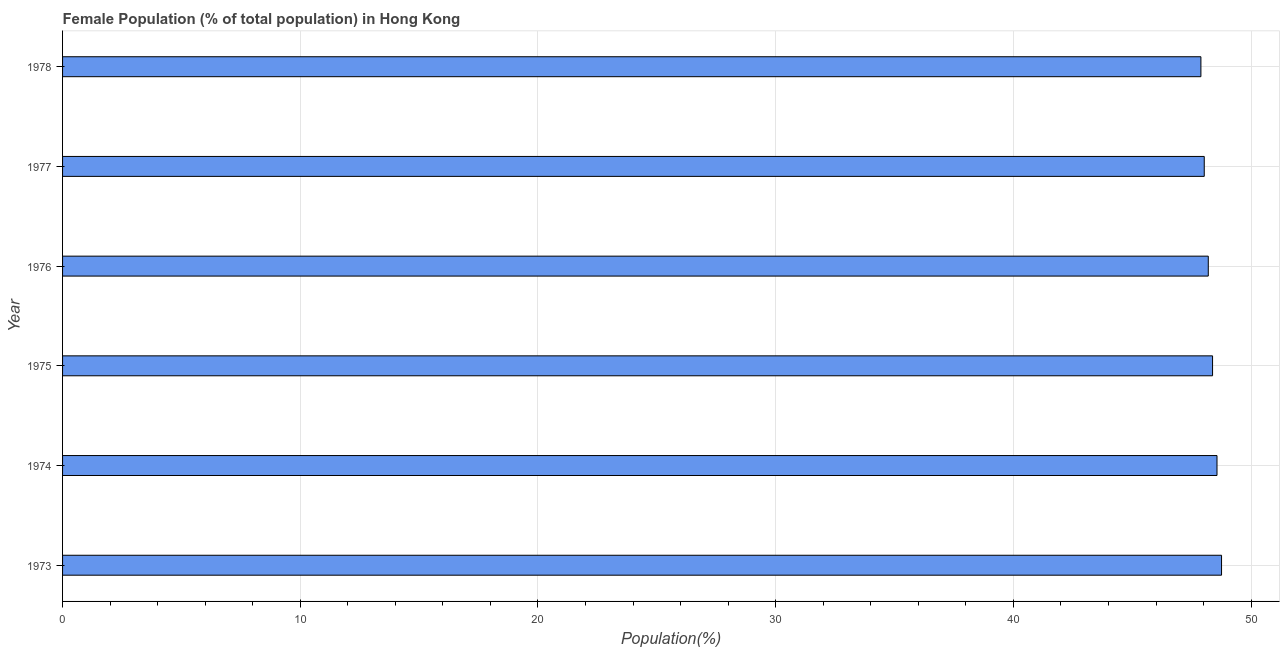What is the title of the graph?
Make the answer very short. Female Population (% of total population) in Hong Kong. What is the label or title of the X-axis?
Your response must be concise. Population(%). What is the female population in 1975?
Ensure brevity in your answer.  48.38. Across all years, what is the maximum female population?
Provide a succinct answer. 48.76. Across all years, what is the minimum female population?
Keep it short and to the point. 47.89. In which year was the female population maximum?
Your answer should be very brief. 1973. In which year was the female population minimum?
Ensure brevity in your answer.  1978. What is the sum of the female population?
Offer a terse response. 289.82. What is the difference between the female population in 1974 and 1977?
Ensure brevity in your answer.  0.54. What is the average female population per year?
Offer a very short reply. 48.3. What is the median female population?
Give a very brief answer. 48.29. In how many years, is the female population greater than 24 %?
Provide a short and direct response. 6. Do a majority of the years between 1977 and 1973 (inclusive) have female population greater than 10 %?
Give a very brief answer. Yes. Is the difference between the female population in 1973 and 1974 greater than the difference between any two years?
Your response must be concise. No. What is the difference between the highest and the second highest female population?
Provide a short and direct response. 0.19. Is the sum of the female population in 1975 and 1976 greater than the maximum female population across all years?
Offer a terse response. Yes. What is the difference between the highest and the lowest female population?
Keep it short and to the point. 0.87. In how many years, is the female population greater than the average female population taken over all years?
Provide a succinct answer. 3. How many years are there in the graph?
Your answer should be compact. 6. What is the difference between two consecutive major ticks on the X-axis?
Your answer should be very brief. 10. What is the Population(%) of 1973?
Your answer should be very brief. 48.76. What is the Population(%) in 1974?
Your response must be concise. 48.57. What is the Population(%) of 1975?
Keep it short and to the point. 48.38. What is the Population(%) in 1976?
Ensure brevity in your answer.  48.2. What is the Population(%) in 1977?
Provide a succinct answer. 48.03. What is the Population(%) in 1978?
Offer a terse response. 47.89. What is the difference between the Population(%) in 1973 and 1974?
Your response must be concise. 0.19. What is the difference between the Population(%) in 1973 and 1975?
Give a very brief answer. 0.38. What is the difference between the Population(%) in 1973 and 1976?
Provide a short and direct response. 0.56. What is the difference between the Population(%) in 1973 and 1977?
Offer a terse response. 0.73. What is the difference between the Population(%) in 1973 and 1978?
Provide a short and direct response. 0.87. What is the difference between the Population(%) in 1974 and 1975?
Keep it short and to the point. 0.19. What is the difference between the Population(%) in 1974 and 1976?
Provide a short and direct response. 0.37. What is the difference between the Population(%) in 1974 and 1977?
Provide a succinct answer. 0.54. What is the difference between the Population(%) in 1974 and 1978?
Offer a very short reply. 0.68. What is the difference between the Population(%) in 1975 and 1976?
Make the answer very short. 0.18. What is the difference between the Population(%) in 1975 and 1977?
Provide a short and direct response. 0.35. What is the difference between the Population(%) in 1975 and 1978?
Provide a succinct answer. 0.49. What is the difference between the Population(%) in 1976 and 1977?
Provide a succinct answer. 0.17. What is the difference between the Population(%) in 1976 and 1978?
Give a very brief answer. 0.31. What is the difference between the Population(%) in 1977 and 1978?
Make the answer very short. 0.14. What is the ratio of the Population(%) in 1973 to that in 1974?
Your response must be concise. 1. What is the ratio of the Population(%) in 1973 to that in 1975?
Offer a terse response. 1.01. What is the ratio of the Population(%) in 1973 to that in 1976?
Your answer should be compact. 1.01. What is the ratio of the Population(%) in 1974 to that in 1977?
Make the answer very short. 1.01. What is the ratio of the Population(%) in 1974 to that in 1978?
Your response must be concise. 1.01. What is the ratio of the Population(%) in 1975 to that in 1978?
Keep it short and to the point. 1.01. What is the ratio of the Population(%) in 1976 to that in 1978?
Your answer should be very brief. 1.01. 